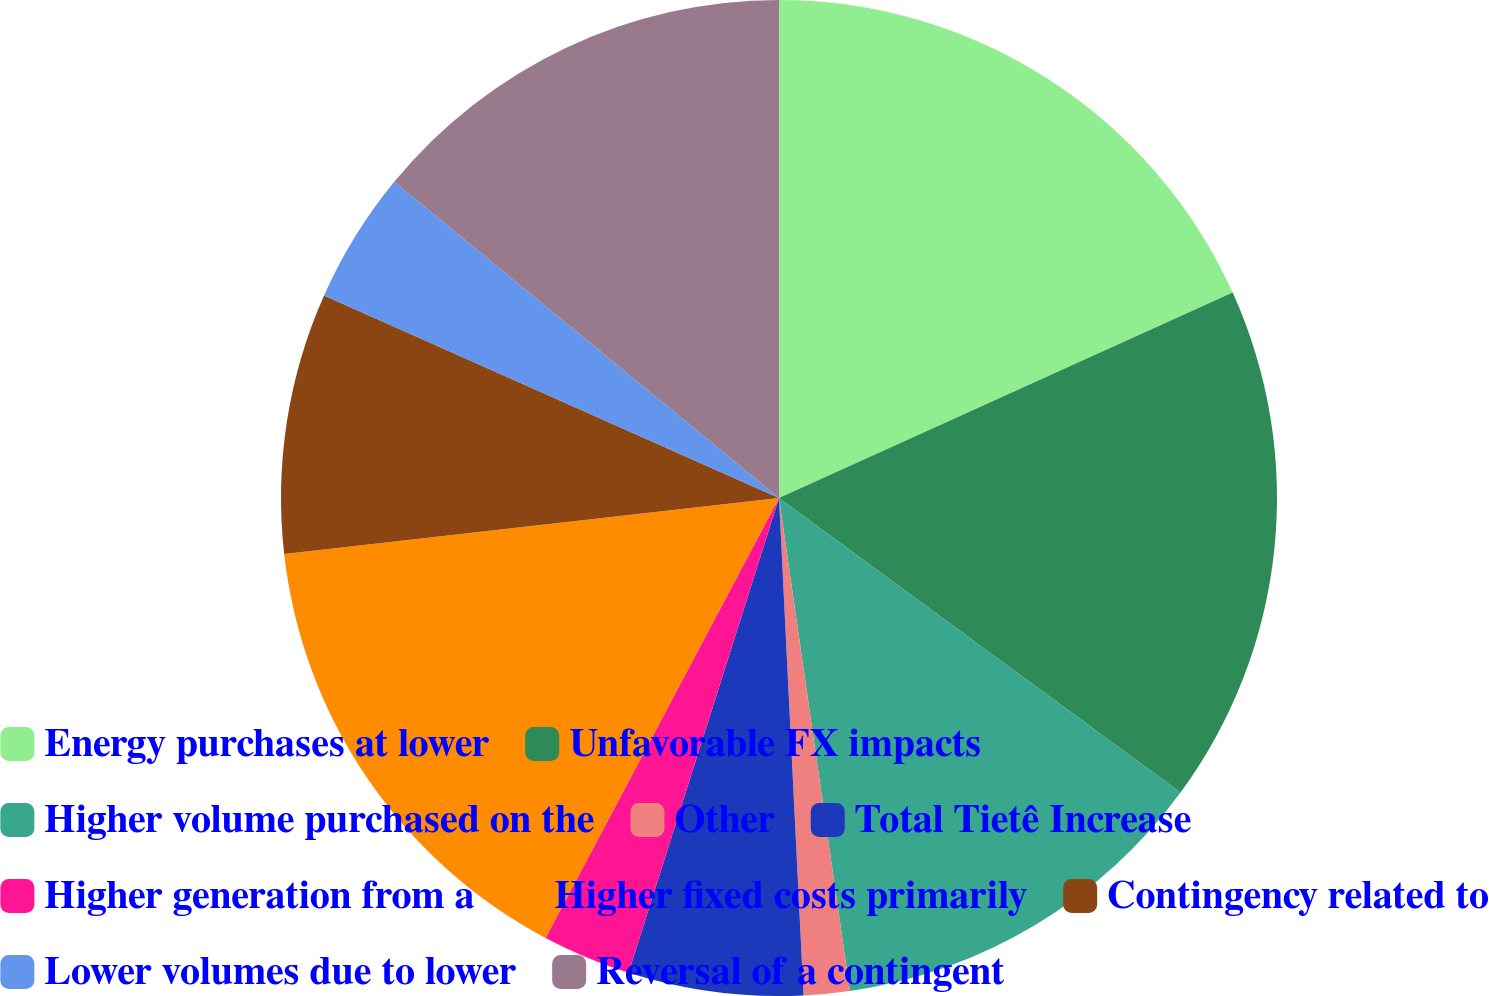<chart> <loc_0><loc_0><loc_500><loc_500><pie_chart><fcel>Energy purchases at lower<fcel>Unfavorable FX impacts<fcel>Higher volume purchased on the<fcel>Other<fcel>Total Tietê Increase<fcel>Higher generation from a<fcel>Higher fixed costs primarily<fcel>Contingency related to<fcel>Lower volumes due to lower<fcel>Reversal of a contingent<nl><fcel>18.23%<fcel>16.84%<fcel>12.65%<fcel>1.49%<fcel>5.67%<fcel>2.88%<fcel>15.44%<fcel>8.46%<fcel>4.28%<fcel>14.05%<nl></chart> 